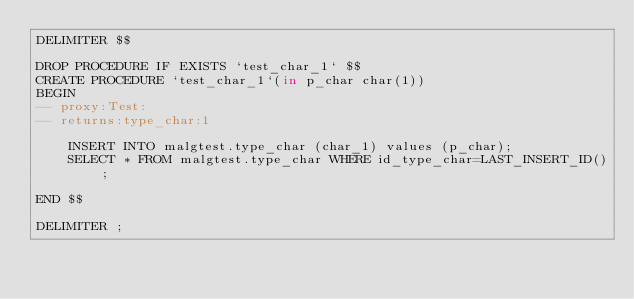<code> <loc_0><loc_0><loc_500><loc_500><_SQL_>DELIMITER $$

DROP PROCEDURE IF EXISTS `test_char_1` $$
CREATE PROCEDURE `test_char_1`(in p_char char(1))
BEGIN
-- proxy:Test:
-- returns:type_char:1

	INSERT INTO malgtest.type_char (char_1) values (p_char);
	SELECT * FROM malgtest.type_char WHERE id_type_char=LAST_INSERT_ID();

END $$

DELIMITER ;</code> 